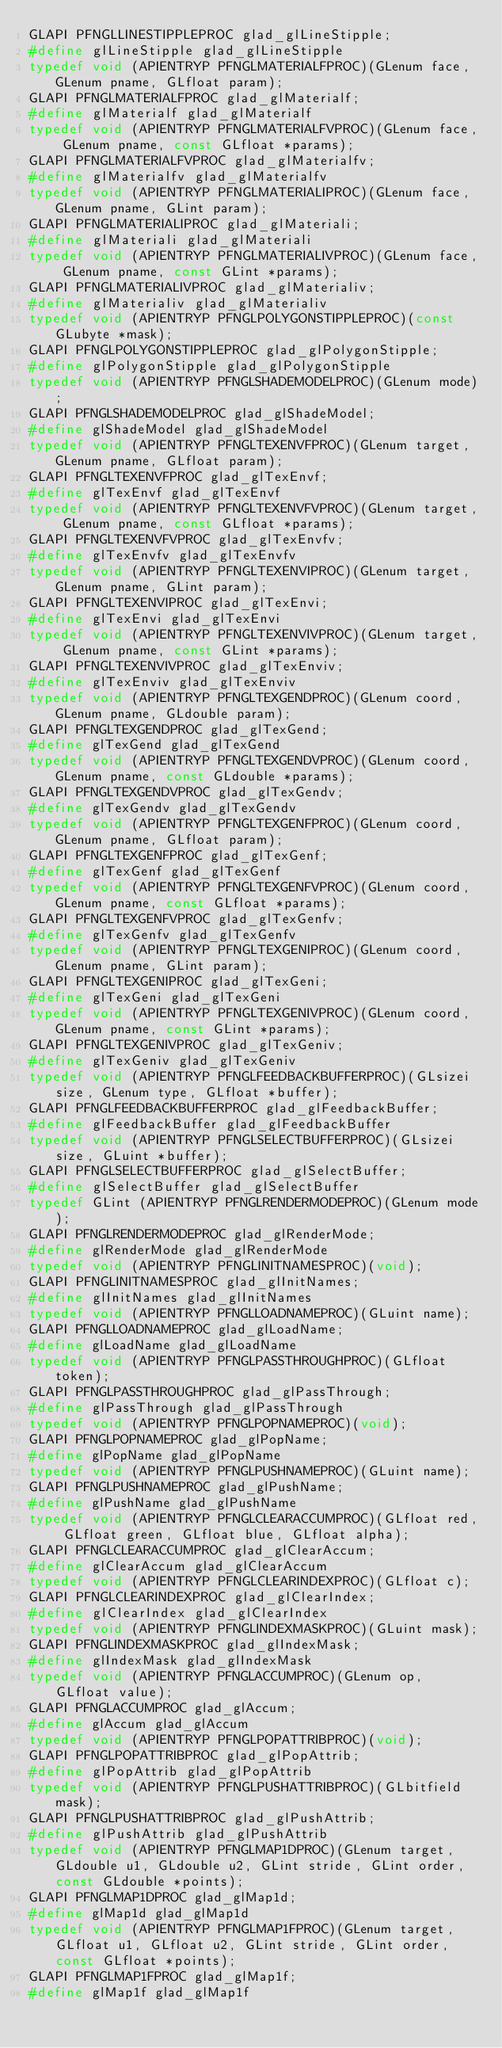<code> <loc_0><loc_0><loc_500><loc_500><_C_>GLAPI PFNGLLINESTIPPLEPROC glad_glLineStipple;
#define glLineStipple glad_glLineStipple
typedef void (APIENTRYP PFNGLMATERIALFPROC)(GLenum face, GLenum pname, GLfloat param);
GLAPI PFNGLMATERIALFPROC glad_glMaterialf;
#define glMaterialf glad_glMaterialf
typedef void (APIENTRYP PFNGLMATERIALFVPROC)(GLenum face, GLenum pname, const GLfloat *params);
GLAPI PFNGLMATERIALFVPROC glad_glMaterialfv;
#define glMaterialfv glad_glMaterialfv
typedef void (APIENTRYP PFNGLMATERIALIPROC)(GLenum face, GLenum pname, GLint param);
GLAPI PFNGLMATERIALIPROC glad_glMateriali;
#define glMateriali glad_glMateriali
typedef void (APIENTRYP PFNGLMATERIALIVPROC)(GLenum face, GLenum pname, const GLint *params);
GLAPI PFNGLMATERIALIVPROC glad_glMaterialiv;
#define glMaterialiv glad_glMaterialiv
typedef void (APIENTRYP PFNGLPOLYGONSTIPPLEPROC)(const GLubyte *mask);
GLAPI PFNGLPOLYGONSTIPPLEPROC glad_glPolygonStipple;
#define glPolygonStipple glad_glPolygonStipple
typedef void (APIENTRYP PFNGLSHADEMODELPROC)(GLenum mode);
GLAPI PFNGLSHADEMODELPROC glad_glShadeModel;
#define glShadeModel glad_glShadeModel
typedef void (APIENTRYP PFNGLTEXENVFPROC)(GLenum target, GLenum pname, GLfloat param);
GLAPI PFNGLTEXENVFPROC glad_glTexEnvf;
#define glTexEnvf glad_glTexEnvf
typedef void (APIENTRYP PFNGLTEXENVFVPROC)(GLenum target, GLenum pname, const GLfloat *params);
GLAPI PFNGLTEXENVFVPROC glad_glTexEnvfv;
#define glTexEnvfv glad_glTexEnvfv
typedef void (APIENTRYP PFNGLTEXENVIPROC)(GLenum target, GLenum pname, GLint param);
GLAPI PFNGLTEXENVIPROC glad_glTexEnvi;
#define glTexEnvi glad_glTexEnvi
typedef void (APIENTRYP PFNGLTEXENVIVPROC)(GLenum target, GLenum pname, const GLint *params);
GLAPI PFNGLTEXENVIVPROC glad_glTexEnviv;
#define glTexEnviv glad_glTexEnviv
typedef void (APIENTRYP PFNGLTEXGENDPROC)(GLenum coord, GLenum pname, GLdouble param);
GLAPI PFNGLTEXGENDPROC glad_glTexGend;
#define glTexGend glad_glTexGend
typedef void (APIENTRYP PFNGLTEXGENDVPROC)(GLenum coord, GLenum pname, const GLdouble *params);
GLAPI PFNGLTEXGENDVPROC glad_glTexGendv;
#define glTexGendv glad_glTexGendv
typedef void (APIENTRYP PFNGLTEXGENFPROC)(GLenum coord, GLenum pname, GLfloat param);
GLAPI PFNGLTEXGENFPROC glad_glTexGenf;
#define glTexGenf glad_glTexGenf
typedef void (APIENTRYP PFNGLTEXGENFVPROC)(GLenum coord, GLenum pname, const GLfloat *params);
GLAPI PFNGLTEXGENFVPROC glad_glTexGenfv;
#define glTexGenfv glad_glTexGenfv
typedef void (APIENTRYP PFNGLTEXGENIPROC)(GLenum coord, GLenum pname, GLint param);
GLAPI PFNGLTEXGENIPROC glad_glTexGeni;
#define glTexGeni glad_glTexGeni
typedef void (APIENTRYP PFNGLTEXGENIVPROC)(GLenum coord, GLenum pname, const GLint *params);
GLAPI PFNGLTEXGENIVPROC glad_glTexGeniv;
#define glTexGeniv glad_glTexGeniv
typedef void (APIENTRYP PFNGLFEEDBACKBUFFERPROC)(GLsizei size, GLenum type, GLfloat *buffer);
GLAPI PFNGLFEEDBACKBUFFERPROC glad_glFeedbackBuffer;
#define glFeedbackBuffer glad_glFeedbackBuffer
typedef void (APIENTRYP PFNGLSELECTBUFFERPROC)(GLsizei size, GLuint *buffer);
GLAPI PFNGLSELECTBUFFERPROC glad_glSelectBuffer;
#define glSelectBuffer glad_glSelectBuffer
typedef GLint (APIENTRYP PFNGLRENDERMODEPROC)(GLenum mode);
GLAPI PFNGLRENDERMODEPROC glad_glRenderMode;
#define glRenderMode glad_glRenderMode
typedef void (APIENTRYP PFNGLINITNAMESPROC)(void);
GLAPI PFNGLINITNAMESPROC glad_glInitNames;
#define glInitNames glad_glInitNames
typedef void (APIENTRYP PFNGLLOADNAMEPROC)(GLuint name);
GLAPI PFNGLLOADNAMEPROC glad_glLoadName;
#define glLoadName glad_glLoadName
typedef void (APIENTRYP PFNGLPASSTHROUGHPROC)(GLfloat token);
GLAPI PFNGLPASSTHROUGHPROC glad_glPassThrough;
#define glPassThrough glad_glPassThrough
typedef void (APIENTRYP PFNGLPOPNAMEPROC)(void);
GLAPI PFNGLPOPNAMEPROC glad_glPopName;
#define glPopName glad_glPopName
typedef void (APIENTRYP PFNGLPUSHNAMEPROC)(GLuint name);
GLAPI PFNGLPUSHNAMEPROC glad_glPushName;
#define glPushName glad_glPushName
typedef void (APIENTRYP PFNGLCLEARACCUMPROC)(GLfloat red, GLfloat green, GLfloat blue, GLfloat alpha);
GLAPI PFNGLCLEARACCUMPROC glad_glClearAccum;
#define glClearAccum glad_glClearAccum
typedef void (APIENTRYP PFNGLCLEARINDEXPROC)(GLfloat c);
GLAPI PFNGLCLEARINDEXPROC glad_glClearIndex;
#define glClearIndex glad_glClearIndex
typedef void (APIENTRYP PFNGLINDEXMASKPROC)(GLuint mask);
GLAPI PFNGLINDEXMASKPROC glad_glIndexMask;
#define glIndexMask glad_glIndexMask
typedef void (APIENTRYP PFNGLACCUMPROC)(GLenum op, GLfloat value);
GLAPI PFNGLACCUMPROC glad_glAccum;
#define glAccum glad_glAccum
typedef void (APIENTRYP PFNGLPOPATTRIBPROC)(void);
GLAPI PFNGLPOPATTRIBPROC glad_glPopAttrib;
#define glPopAttrib glad_glPopAttrib
typedef void (APIENTRYP PFNGLPUSHATTRIBPROC)(GLbitfield mask);
GLAPI PFNGLPUSHATTRIBPROC glad_glPushAttrib;
#define glPushAttrib glad_glPushAttrib
typedef void (APIENTRYP PFNGLMAP1DPROC)(GLenum target, GLdouble u1, GLdouble u2, GLint stride, GLint order, const GLdouble *points);
GLAPI PFNGLMAP1DPROC glad_glMap1d;
#define glMap1d glad_glMap1d
typedef void (APIENTRYP PFNGLMAP1FPROC)(GLenum target, GLfloat u1, GLfloat u2, GLint stride, GLint order, const GLfloat *points);
GLAPI PFNGLMAP1FPROC glad_glMap1f;
#define glMap1f glad_glMap1f</code> 